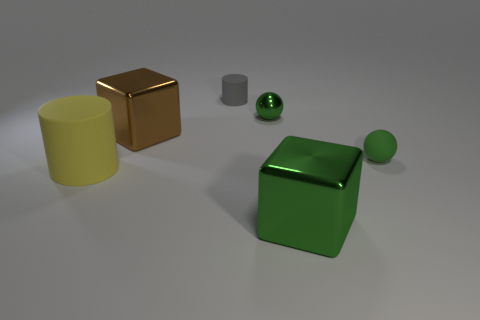Add 3 tiny objects. How many objects exist? 9 Subtract all balls. How many objects are left? 4 Subtract 0 gray blocks. How many objects are left? 6 Subtract all cubes. Subtract all small gray cylinders. How many objects are left? 3 Add 3 small objects. How many small objects are left? 6 Add 3 small spheres. How many small spheres exist? 5 